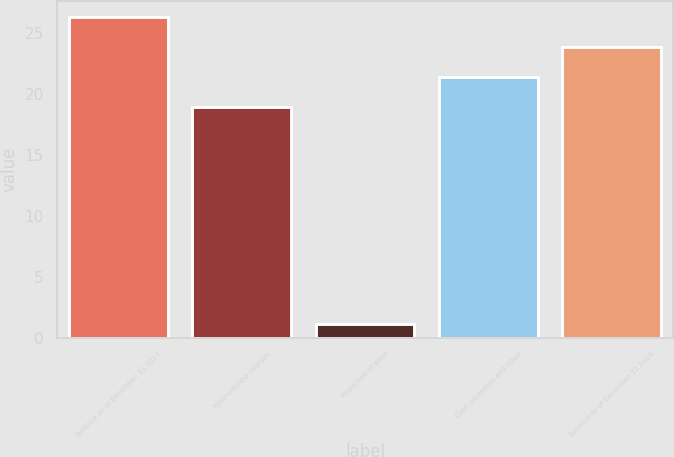<chart> <loc_0><loc_0><loc_500><loc_500><bar_chart><fcel>Balance as of December 31 2013<fcel>Restructuring charges<fcel>Reduction of prior<fcel>Cash payments and other<fcel>Balance as of December 31 2014<nl><fcel>26.32<fcel>18.9<fcel>1.1<fcel>21.4<fcel>23.86<nl></chart> 